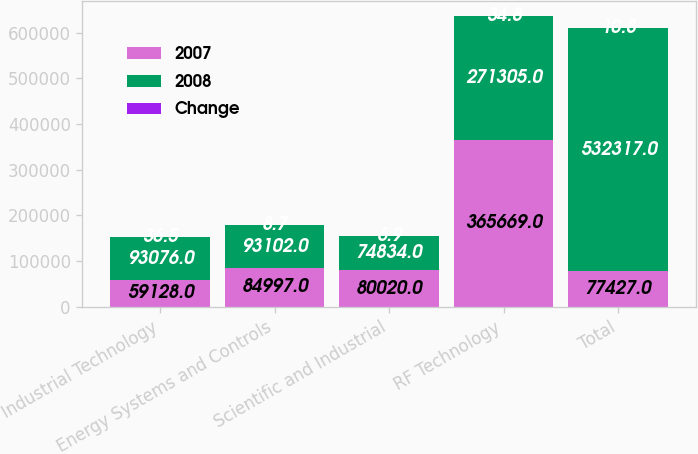Convert chart. <chart><loc_0><loc_0><loc_500><loc_500><stacked_bar_chart><ecel><fcel>Industrial Technology<fcel>Energy Systems and Controls<fcel>Scientific and Industrial<fcel>RF Technology<fcel>Total<nl><fcel>2007<fcel>59128<fcel>84997<fcel>80020<fcel>365669<fcel>77427<nl><fcel>2008<fcel>93076<fcel>93102<fcel>74834<fcel>271305<fcel>532317<nl><fcel>Change<fcel>36.5<fcel>8.7<fcel>6.9<fcel>34.8<fcel>10.8<nl></chart> 